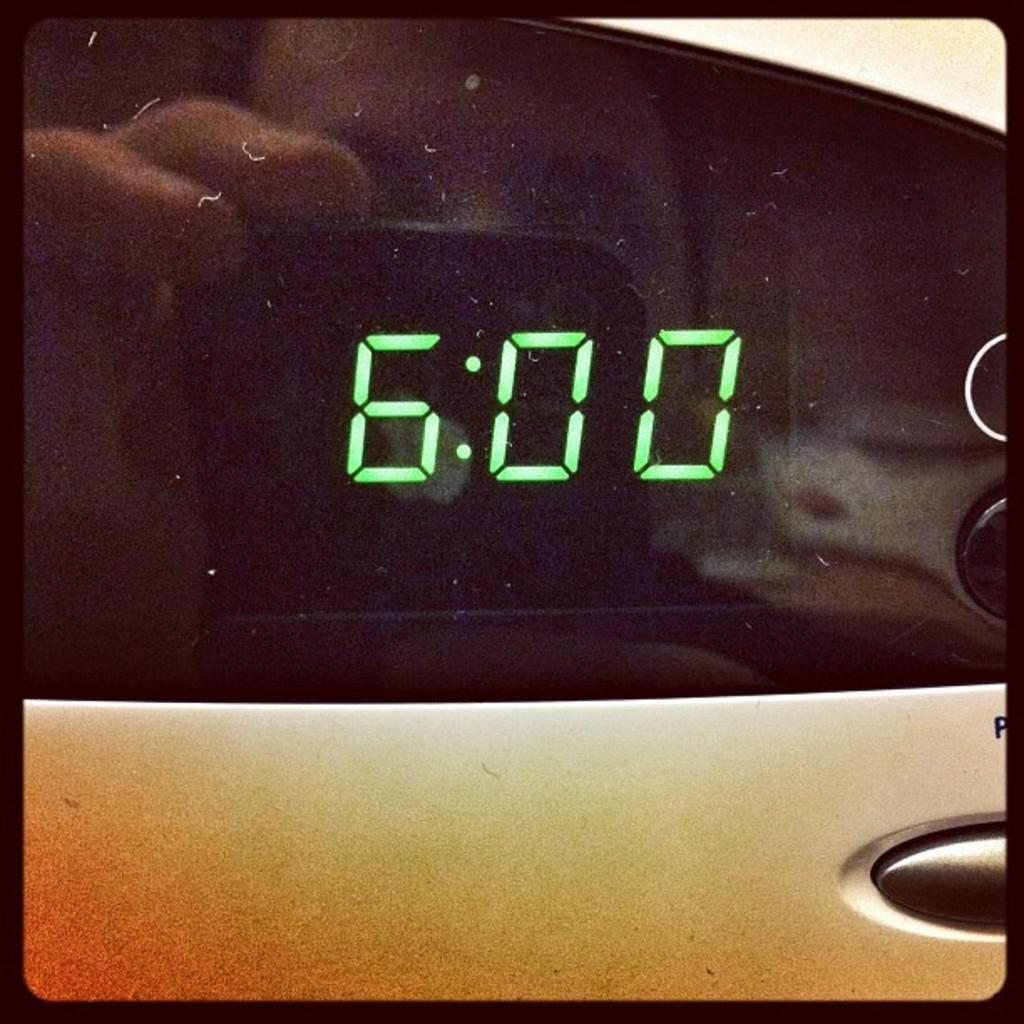<image>
Create a compact narrative representing the image presented. A digital clock display with 6:00 glowing in green. 